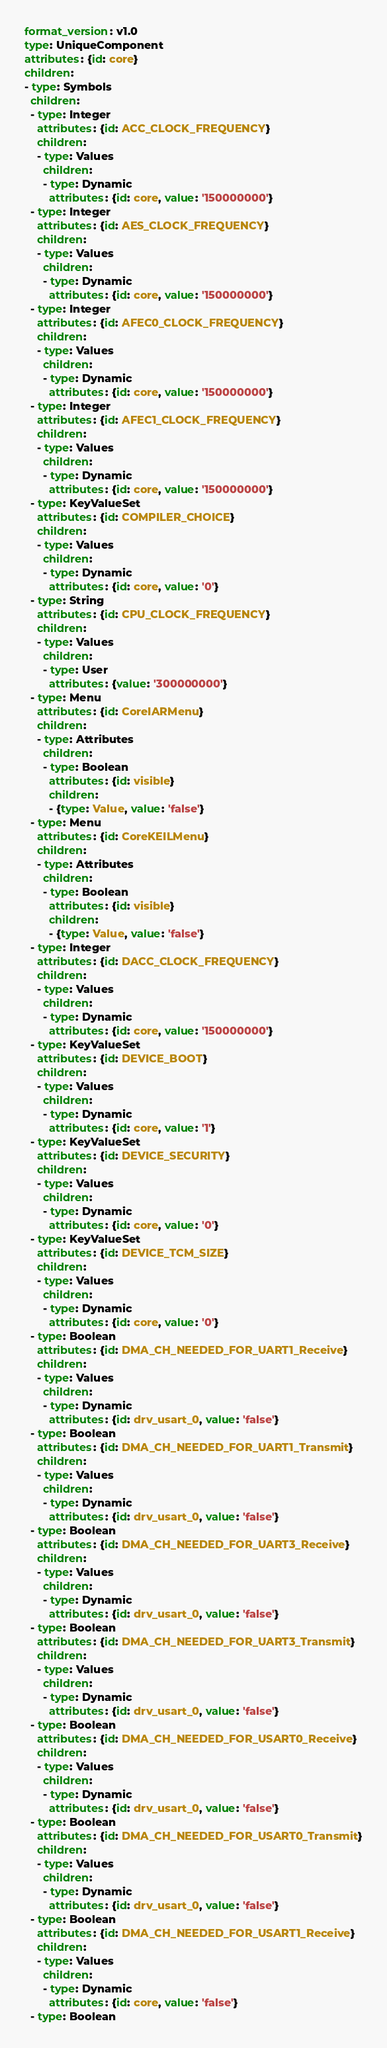Convert code to text. <code><loc_0><loc_0><loc_500><loc_500><_YAML_>format_version: v1.0
type: UniqueComponent
attributes: {id: core}
children:
- type: Symbols
  children:
  - type: Integer
    attributes: {id: ACC_CLOCK_FREQUENCY}
    children:
    - type: Values
      children:
      - type: Dynamic
        attributes: {id: core, value: '150000000'}
  - type: Integer
    attributes: {id: AES_CLOCK_FREQUENCY}
    children:
    - type: Values
      children:
      - type: Dynamic
        attributes: {id: core, value: '150000000'}
  - type: Integer
    attributes: {id: AFEC0_CLOCK_FREQUENCY}
    children:
    - type: Values
      children:
      - type: Dynamic
        attributes: {id: core, value: '150000000'}
  - type: Integer
    attributes: {id: AFEC1_CLOCK_FREQUENCY}
    children:
    - type: Values
      children:
      - type: Dynamic
        attributes: {id: core, value: '150000000'}
  - type: KeyValueSet
    attributes: {id: COMPILER_CHOICE}
    children:
    - type: Values
      children:
      - type: Dynamic
        attributes: {id: core, value: '0'}
  - type: String
    attributes: {id: CPU_CLOCK_FREQUENCY}
    children:
    - type: Values
      children:
      - type: User
        attributes: {value: '300000000'}
  - type: Menu
    attributes: {id: CoreIARMenu}
    children:
    - type: Attributes
      children:
      - type: Boolean
        attributes: {id: visible}
        children:
        - {type: Value, value: 'false'}
  - type: Menu
    attributes: {id: CoreKEILMenu}
    children:
    - type: Attributes
      children:
      - type: Boolean
        attributes: {id: visible}
        children:
        - {type: Value, value: 'false'}
  - type: Integer
    attributes: {id: DACC_CLOCK_FREQUENCY}
    children:
    - type: Values
      children:
      - type: Dynamic
        attributes: {id: core, value: '150000000'}
  - type: KeyValueSet
    attributes: {id: DEVICE_BOOT}
    children:
    - type: Values
      children:
      - type: Dynamic
        attributes: {id: core, value: '1'}
  - type: KeyValueSet
    attributes: {id: DEVICE_SECURITY}
    children:
    - type: Values
      children:
      - type: Dynamic
        attributes: {id: core, value: '0'}
  - type: KeyValueSet
    attributes: {id: DEVICE_TCM_SIZE}
    children:
    - type: Values
      children:
      - type: Dynamic
        attributes: {id: core, value: '0'}
  - type: Boolean
    attributes: {id: DMA_CH_NEEDED_FOR_UART1_Receive}
    children:
    - type: Values
      children:
      - type: Dynamic
        attributes: {id: drv_usart_0, value: 'false'}
  - type: Boolean
    attributes: {id: DMA_CH_NEEDED_FOR_UART1_Transmit}
    children:
    - type: Values
      children:
      - type: Dynamic
        attributes: {id: drv_usart_0, value: 'false'}
  - type: Boolean
    attributes: {id: DMA_CH_NEEDED_FOR_UART3_Receive}
    children:
    - type: Values
      children:
      - type: Dynamic
        attributes: {id: drv_usart_0, value: 'false'}
  - type: Boolean
    attributes: {id: DMA_CH_NEEDED_FOR_UART3_Transmit}
    children:
    - type: Values
      children:
      - type: Dynamic
        attributes: {id: drv_usart_0, value: 'false'}
  - type: Boolean
    attributes: {id: DMA_CH_NEEDED_FOR_USART0_Receive}
    children:
    - type: Values
      children:
      - type: Dynamic
        attributes: {id: drv_usart_0, value: 'false'}
  - type: Boolean
    attributes: {id: DMA_CH_NEEDED_FOR_USART0_Transmit}
    children:
    - type: Values
      children:
      - type: Dynamic
        attributes: {id: drv_usart_0, value: 'false'}
  - type: Boolean
    attributes: {id: DMA_CH_NEEDED_FOR_USART1_Receive}
    children:
    - type: Values
      children:
      - type: Dynamic
        attributes: {id: core, value: 'false'}
  - type: Boolean</code> 